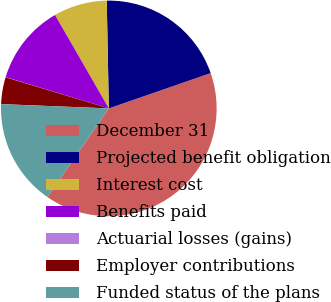Convert chart to OTSL. <chart><loc_0><loc_0><loc_500><loc_500><pie_chart><fcel>December 31<fcel>Projected benefit obligation<fcel>Interest cost<fcel>Benefits paid<fcel>Actuarial losses (gains)<fcel>Employer contributions<fcel>Funded status of the plans<nl><fcel>39.95%<fcel>19.99%<fcel>8.01%<fcel>12.0%<fcel>0.03%<fcel>4.02%<fcel>16.0%<nl></chart> 